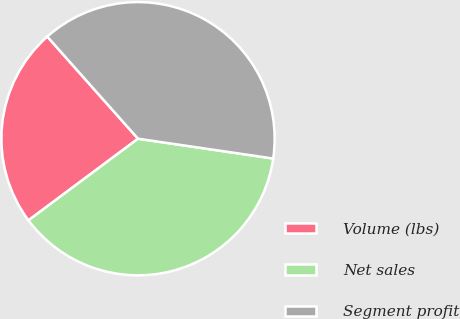Convert chart. <chart><loc_0><loc_0><loc_500><loc_500><pie_chart><fcel>Volume (lbs)<fcel>Net sales<fcel>Segment profit<nl><fcel>23.63%<fcel>37.49%<fcel>38.88%<nl></chart> 